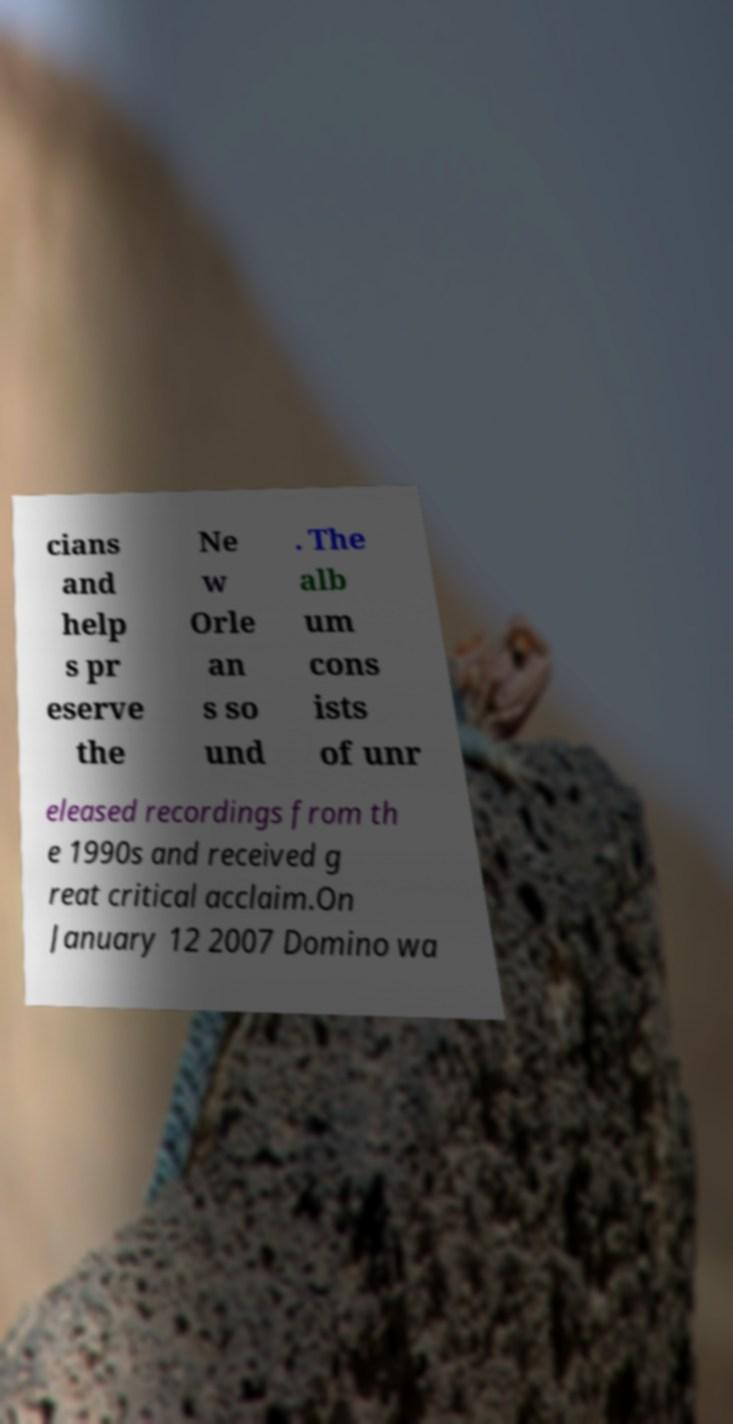What messages or text are displayed in this image? I need them in a readable, typed format. cians and help s pr eserve the Ne w Orle an s so und . The alb um cons ists of unr eleased recordings from th e 1990s and received g reat critical acclaim.On January 12 2007 Domino wa 